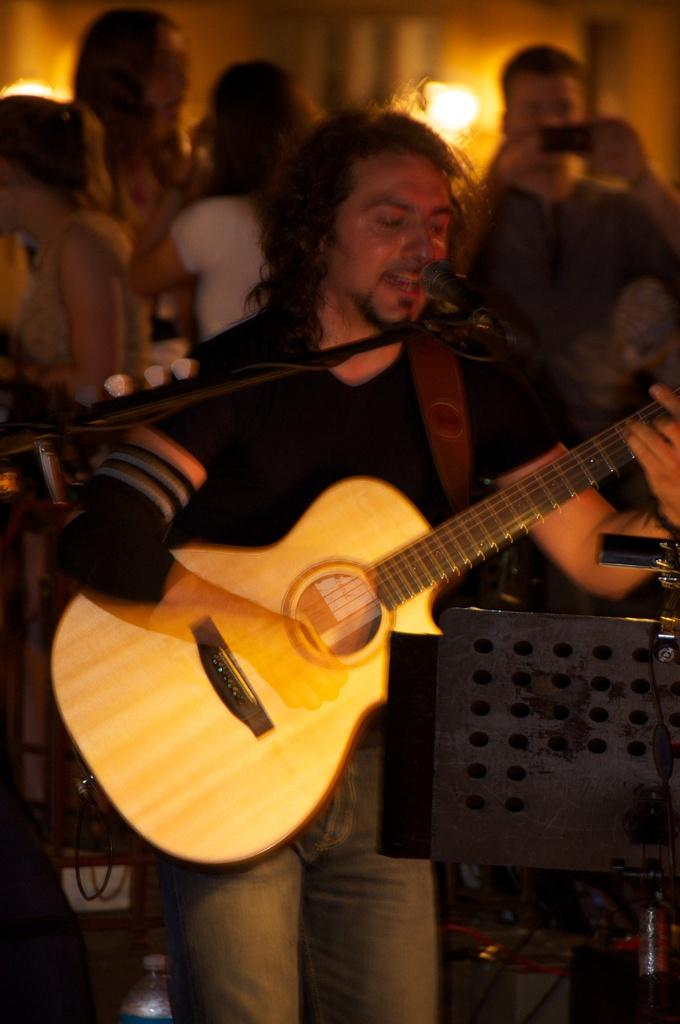What can be seen in the image? There are people standing in the image. What object is present that is typically used for amplifying sound? There is a microphone in the image. What musical instrument is being held by a person in the image? A man is holding a guitar in the image. What type of cream can be seen in the man's pocket in the image? There is no cream or pocket visible in the image; the man is holding a guitar. 